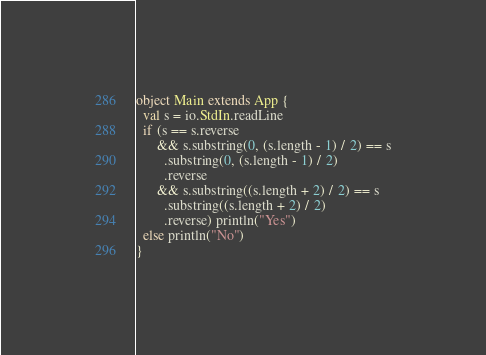Convert code to text. <code><loc_0><loc_0><loc_500><loc_500><_Scala_>object Main extends App {
  val s = io.StdIn.readLine
  if (s == s.reverse
      && s.substring(0, (s.length - 1) / 2) == s
        .substring(0, (s.length - 1) / 2)
        .reverse
      && s.substring((s.length + 2) / 2) == s
        .substring((s.length + 2) / 2)
        .reverse) println("Yes")
  else println("No")
}
</code> 